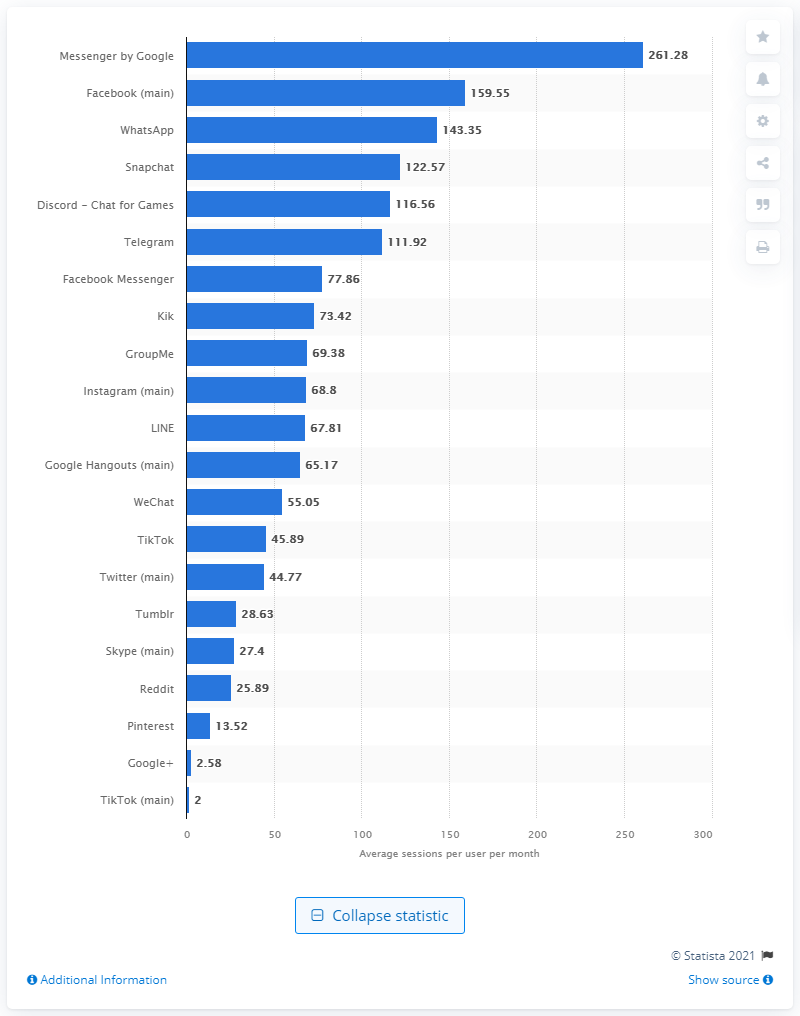Mention a couple of crucial points in this snapshot. In the month, mobile Facebook users accessed the social networking platform 159.55 times on average. 